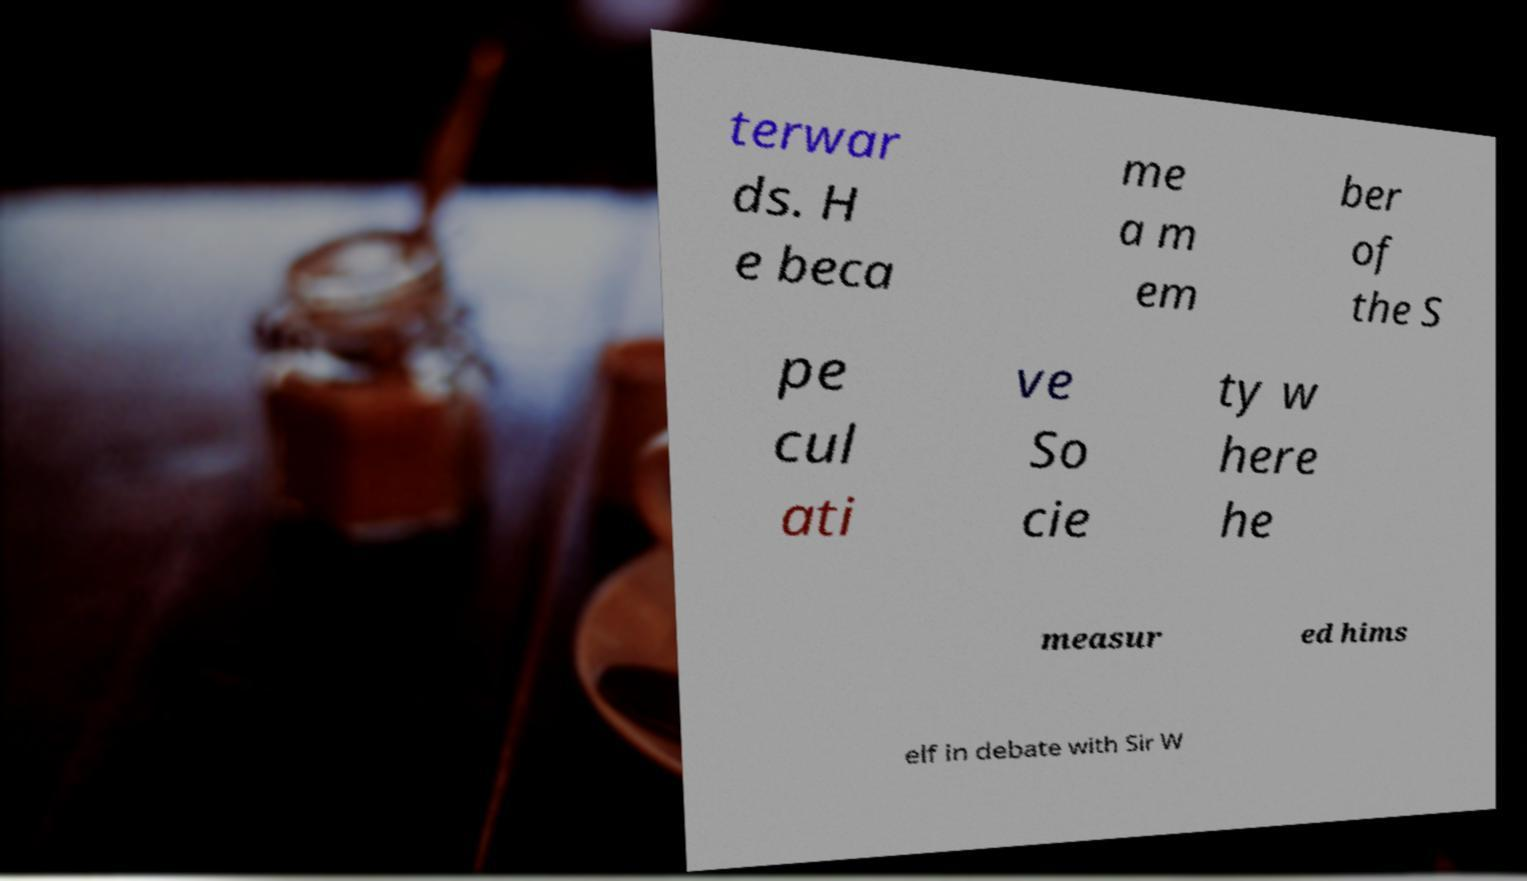Can you read and provide the text displayed in the image?This photo seems to have some interesting text. Can you extract and type it out for me? terwar ds. H e beca me a m em ber of the S pe cul ati ve So cie ty w here he measur ed hims elf in debate with Sir W 